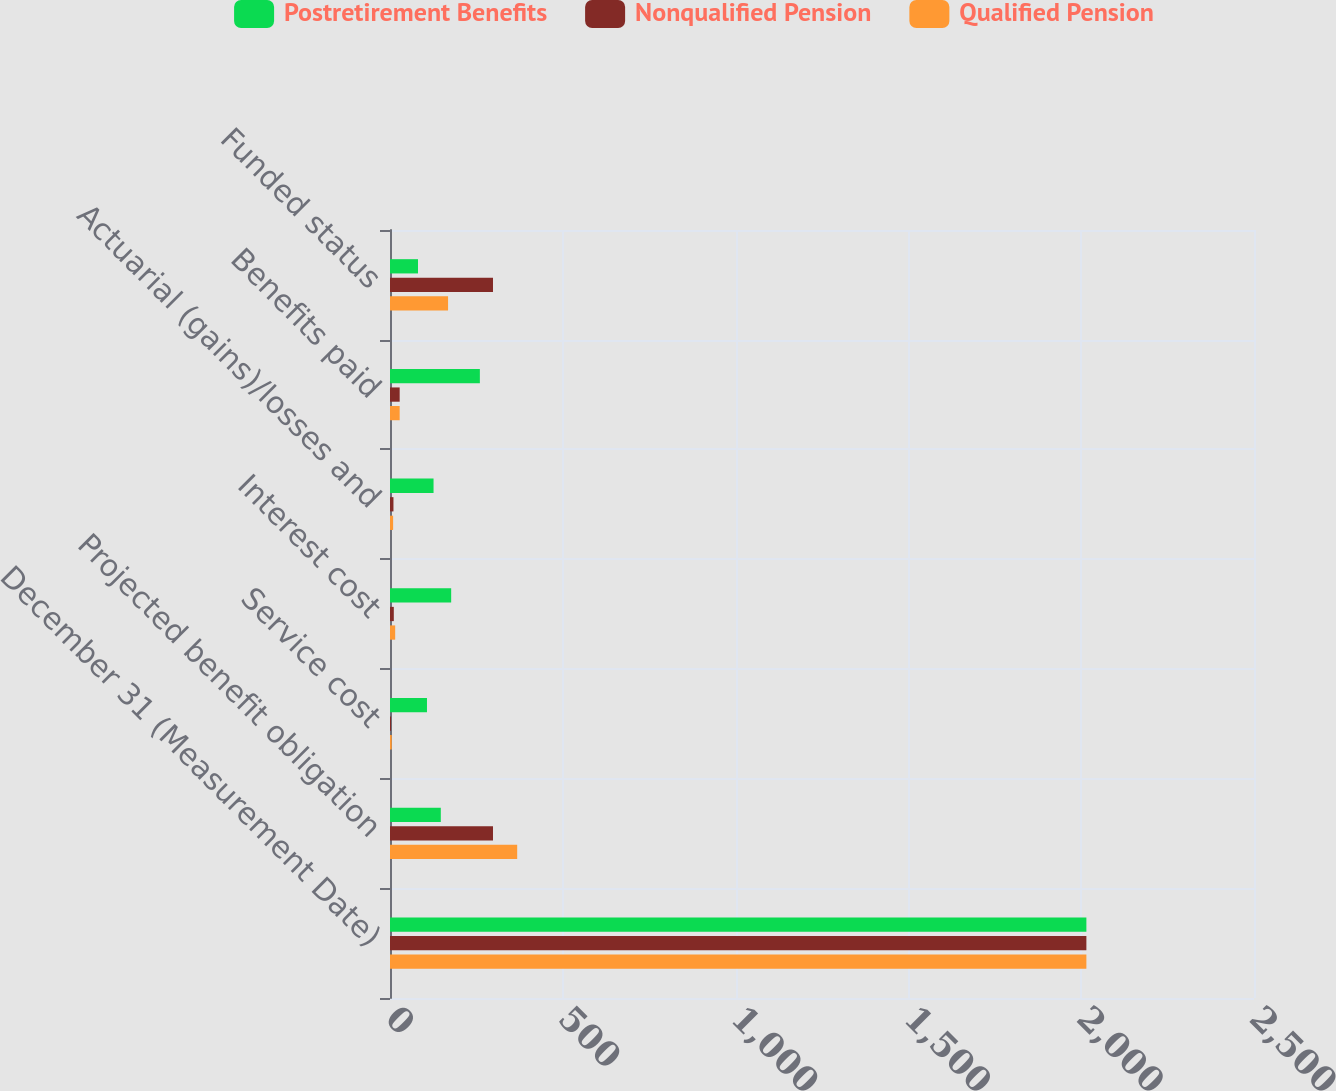<chart> <loc_0><loc_0><loc_500><loc_500><stacked_bar_chart><ecel><fcel>December 31 (Measurement Date)<fcel>Projected benefit obligation<fcel>Service cost<fcel>Interest cost<fcel>Actuarial (gains)/losses and<fcel>Benefits paid<fcel>Funded status<nl><fcel>Postretirement Benefits<fcel>2015<fcel>147<fcel>107<fcel>177<fcel>126<fcel>260<fcel>81<nl><fcel>Nonqualified Pension<fcel>2015<fcel>298<fcel>3<fcel>11<fcel>10<fcel>28<fcel>298<nl><fcel>Qualified Pension<fcel>2015<fcel>368<fcel>5<fcel>15<fcel>9<fcel>28<fcel>168<nl></chart> 